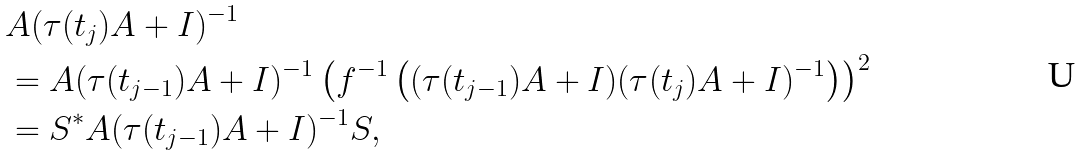Convert formula to latex. <formula><loc_0><loc_0><loc_500><loc_500>& A ( \tau ( t _ { j } ) A + I ) ^ { - 1 } \\ & = A ( \tau ( t _ { j - 1 } ) A + I ) ^ { - 1 } \left ( f ^ { - 1 } \left ( ( \tau ( t _ { j - 1 } ) A + I ) ( \tau ( t _ { j } ) A + I ) ^ { - 1 } \right ) \right ) ^ { 2 } \\ & = S ^ { * } A ( \tau ( t _ { j - 1 } ) A + I ) ^ { - 1 } S ,</formula> 